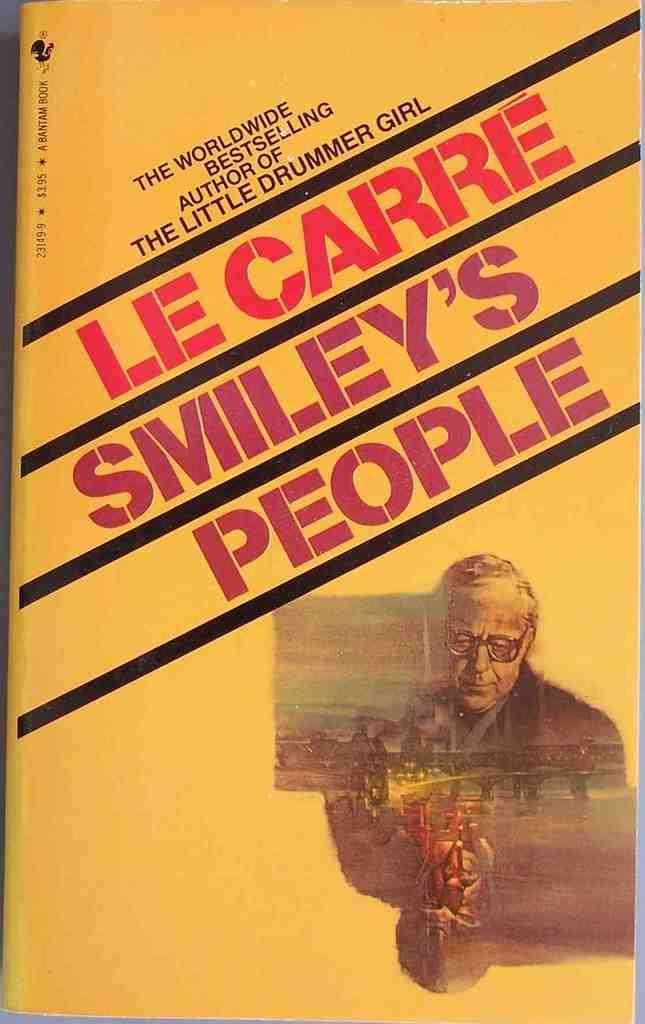<image>
Create a compact narrative representing the image presented. A book published by Bantam has an old man on the cover. 